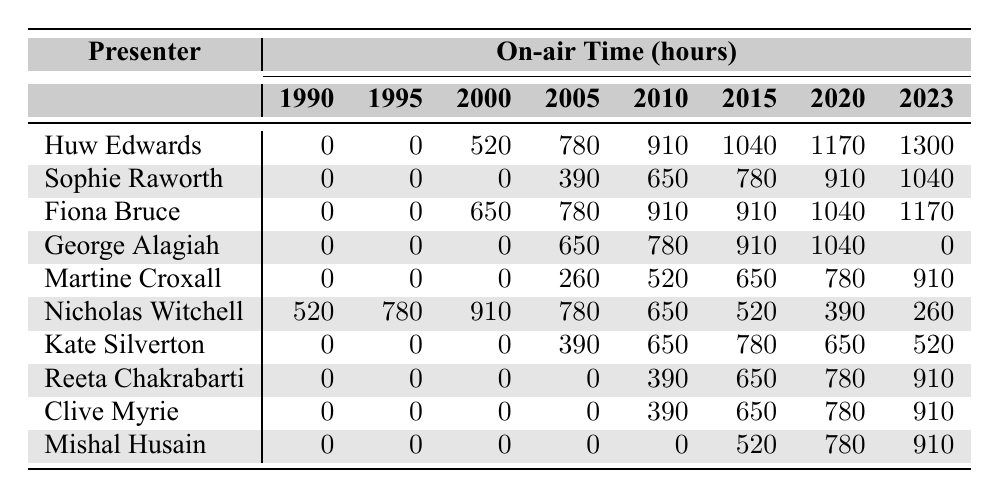What was Huw Edwards' on-air time in 2020? According to the table, Huw Edwards recorded 1170 hours of on-air time in 2020.
Answer: 1170 Which presenter had the highest on-air time in 2015? Fiona Bruce had the highest on-air time in 2015 with 910 hours.
Answer: 910 Did George Alagiah have any on-air time in 2023? No, George Alagiah had 0 hours of on-air time in 2023.
Answer: No How much did Martine Croxall's on-air time increase from 2010 to 2023? Martine Croxall's on-air time in 2010 was 650 hours, and in 2023 it was 910 hours. The increase is 910 - 650 = 260 hours.
Answer: 260 What is the average on-air time for Fiona Bruce from 2005 to 2023? Fiona Bruce's on-air times for the years 2005, 2010, 2015, 2020, and 2023 are 780, 910, 910, 1040, and 1170 respectively. The sum is 780 + 910 + 910 + 1040 + 1170 = 4820. There are 5 data points, so the average is 4820 / 5 = 964.
Answer: 964 Which year saw the most hours for Nicholas Witchell? Nicholas Witchell had the most hours in 2010 with 650 hours.
Answer: 650 What was the total on-air time for Sophie Raworth from 2000 to 2023? Sophie Raworth's on-air times from 2000 to 2023 are 0, 390, 650, 780, 910, and 1040 respectively. The total is 0 + 390 + 650 + 780 + 910 + 1040 = 3770 hours.
Answer: 3770 Who had the least on-air time in 1990? In 1990, all presenters except Nicholas Witchell had 0 hours. Thus, the presenters with the least on-air time are Huw Edwards, Sophie Raworth, Fiona Bruce, George Alagiah, Martine Croxall, Kate Silverton, Reeta Chakrabarti, Clive Myrie, and Mishal Husain.
Answer: Multiple presenters What is the difference in on-air time between Huw Edwards and Clive Myrie in 2023? In 2023, Huw Edwards had 1300 hours and Clive Myrie had 910 hours. The difference is 1300 - 910 = 390 hours.
Answer: 390 During which year did Kate Silverton have the least on-air time? Kate Silverton had 0 hours of on-air time in 2000 and 2005, which is the least compared to all other years.
Answer: 2000 and 2005 